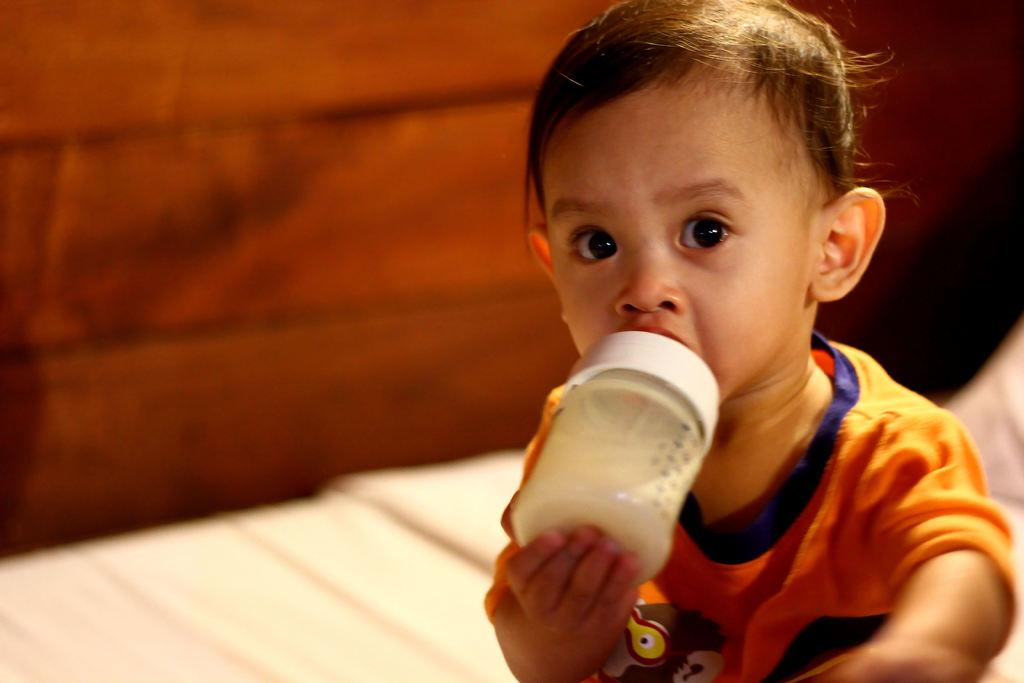What is the main subject of the image? There is a baby in the image. What is the baby holding in the image? The baby is holding a bottle. What can be seen in the background of the image? There is a wall in the background of the image. What type of sign can be seen during the rainstorm in the image? There is no rainstorm or sign present in the image; it features a baby holding a bottle with a wall in the background. 